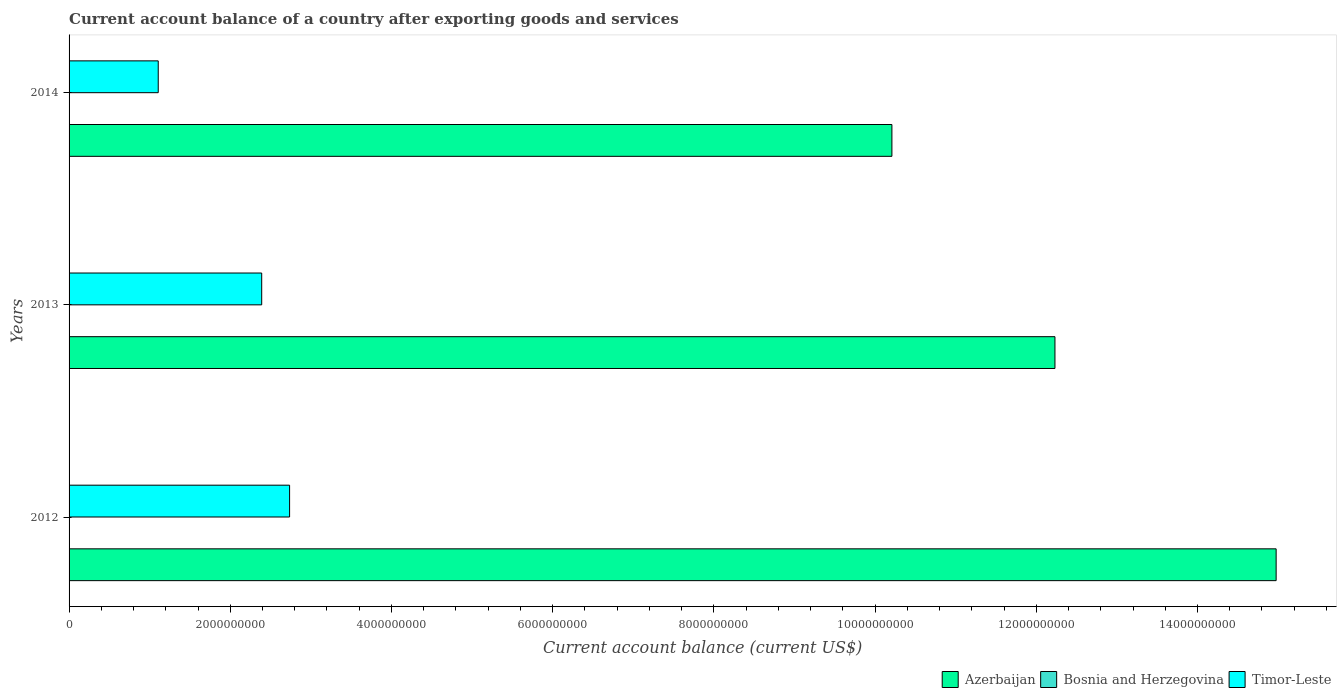Are the number of bars per tick equal to the number of legend labels?
Give a very brief answer. No. In how many cases, is the number of bars for a given year not equal to the number of legend labels?
Your answer should be very brief. 3. What is the account balance in Azerbaijan in 2013?
Your answer should be very brief. 1.22e+1. Across all years, what is the maximum account balance in Timor-Leste?
Give a very brief answer. 2.74e+09. Across all years, what is the minimum account balance in Timor-Leste?
Give a very brief answer. 1.11e+09. In which year was the account balance in Azerbaijan maximum?
Your answer should be very brief. 2012. What is the total account balance in Timor-Leste in the graph?
Your answer should be very brief. 6.23e+09. What is the difference between the account balance in Azerbaijan in 2012 and that in 2014?
Provide a succinct answer. 4.77e+09. What is the difference between the account balance in Bosnia and Herzegovina in 2014 and the account balance in Azerbaijan in 2012?
Keep it short and to the point. -1.50e+1. What is the average account balance in Azerbaijan per year?
Offer a very short reply. 1.25e+1. In the year 2013, what is the difference between the account balance in Azerbaijan and account balance in Timor-Leste?
Your response must be concise. 9.84e+09. What is the ratio of the account balance in Timor-Leste in 2012 to that in 2013?
Ensure brevity in your answer.  1.14. Is the account balance in Azerbaijan in 2012 less than that in 2014?
Give a very brief answer. No. What is the difference between the highest and the second highest account balance in Azerbaijan?
Provide a short and direct response. 2.74e+09. What is the difference between the highest and the lowest account balance in Azerbaijan?
Offer a terse response. 4.77e+09. Is it the case that in every year, the sum of the account balance in Azerbaijan and account balance in Timor-Leste is greater than the account balance in Bosnia and Herzegovina?
Your response must be concise. Yes. What is the difference between two consecutive major ticks on the X-axis?
Provide a succinct answer. 2.00e+09. Are the values on the major ticks of X-axis written in scientific E-notation?
Provide a succinct answer. No. Does the graph contain grids?
Offer a very short reply. No. How many legend labels are there?
Ensure brevity in your answer.  3. How are the legend labels stacked?
Ensure brevity in your answer.  Horizontal. What is the title of the graph?
Your answer should be compact. Current account balance of a country after exporting goods and services. What is the label or title of the X-axis?
Your answer should be very brief. Current account balance (current US$). What is the label or title of the Y-axis?
Ensure brevity in your answer.  Years. What is the Current account balance (current US$) of Azerbaijan in 2012?
Your answer should be very brief. 1.50e+1. What is the Current account balance (current US$) of Timor-Leste in 2012?
Make the answer very short. 2.74e+09. What is the Current account balance (current US$) in Azerbaijan in 2013?
Keep it short and to the point. 1.22e+1. What is the Current account balance (current US$) of Timor-Leste in 2013?
Provide a short and direct response. 2.39e+09. What is the Current account balance (current US$) of Azerbaijan in 2014?
Make the answer very short. 1.02e+1. What is the Current account balance (current US$) in Timor-Leste in 2014?
Provide a succinct answer. 1.11e+09. Across all years, what is the maximum Current account balance (current US$) in Azerbaijan?
Your answer should be very brief. 1.50e+1. Across all years, what is the maximum Current account balance (current US$) of Timor-Leste?
Offer a very short reply. 2.74e+09. Across all years, what is the minimum Current account balance (current US$) of Azerbaijan?
Your response must be concise. 1.02e+1. Across all years, what is the minimum Current account balance (current US$) of Timor-Leste?
Give a very brief answer. 1.11e+09. What is the total Current account balance (current US$) of Azerbaijan in the graph?
Your response must be concise. 3.74e+1. What is the total Current account balance (current US$) of Timor-Leste in the graph?
Provide a short and direct response. 6.23e+09. What is the difference between the Current account balance (current US$) in Azerbaijan in 2012 and that in 2013?
Your response must be concise. 2.74e+09. What is the difference between the Current account balance (current US$) of Timor-Leste in 2012 and that in 2013?
Ensure brevity in your answer.  3.46e+08. What is the difference between the Current account balance (current US$) in Azerbaijan in 2012 and that in 2014?
Your response must be concise. 4.77e+09. What is the difference between the Current account balance (current US$) in Timor-Leste in 2012 and that in 2014?
Ensure brevity in your answer.  1.63e+09. What is the difference between the Current account balance (current US$) of Azerbaijan in 2013 and that in 2014?
Provide a short and direct response. 2.02e+09. What is the difference between the Current account balance (current US$) in Timor-Leste in 2013 and that in 2014?
Keep it short and to the point. 1.28e+09. What is the difference between the Current account balance (current US$) in Azerbaijan in 2012 and the Current account balance (current US$) in Timor-Leste in 2013?
Make the answer very short. 1.26e+1. What is the difference between the Current account balance (current US$) of Azerbaijan in 2012 and the Current account balance (current US$) of Timor-Leste in 2014?
Provide a short and direct response. 1.39e+1. What is the difference between the Current account balance (current US$) of Azerbaijan in 2013 and the Current account balance (current US$) of Timor-Leste in 2014?
Your response must be concise. 1.11e+1. What is the average Current account balance (current US$) in Azerbaijan per year?
Your response must be concise. 1.25e+1. What is the average Current account balance (current US$) in Timor-Leste per year?
Give a very brief answer. 2.08e+09. In the year 2012, what is the difference between the Current account balance (current US$) in Azerbaijan and Current account balance (current US$) in Timor-Leste?
Offer a terse response. 1.22e+1. In the year 2013, what is the difference between the Current account balance (current US$) in Azerbaijan and Current account balance (current US$) in Timor-Leste?
Make the answer very short. 9.84e+09. In the year 2014, what is the difference between the Current account balance (current US$) in Azerbaijan and Current account balance (current US$) in Timor-Leste?
Make the answer very short. 9.10e+09. What is the ratio of the Current account balance (current US$) in Azerbaijan in 2012 to that in 2013?
Your response must be concise. 1.22. What is the ratio of the Current account balance (current US$) in Timor-Leste in 2012 to that in 2013?
Your response must be concise. 1.14. What is the ratio of the Current account balance (current US$) in Azerbaijan in 2012 to that in 2014?
Ensure brevity in your answer.  1.47. What is the ratio of the Current account balance (current US$) of Timor-Leste in 2012 to that in 2014?
Your response must be concise. 2.47. What is the ratio of the Current account balance (current US$) of Azerbaijan in 2013 to that in 2014?
Your response must be concise. 1.2. What is the ratio of the Current account balance (current US$) of Timor-Leste in 2013 to that in 2014?
Give a very brief answer. 2.16. What is the difference between the highest and the second highest Current account balance (current US$) in Azerbaijan?
Offer a very short reply. 2.74e+09. What is the difference between the highest and the second highest Current account balance (current US$) of Timor-Leste?
Keep it short and to the point. 3.46e+08. What is the difference between the highest and the lowest Current account balance (current US$) in Azerbaijan?
Offer a very short reply. 4.77e+09. What is the difference between the highest and the lowest Current account balance (current US$) in Timor-Leste?
Your response must be concise. 1.63e+09. 